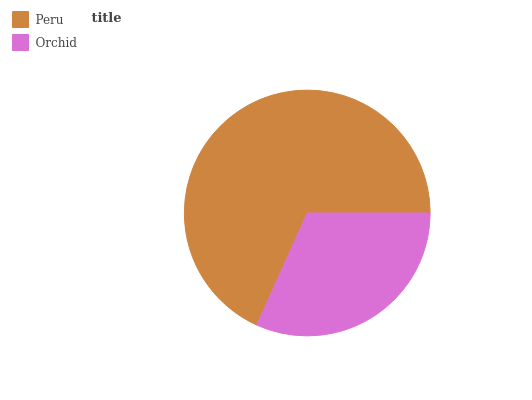Is Orchid the minimum?
Answer yes or no. Yes. Is Peru the maximum?
Answer yes or no. Yes. Is Orchid the maximum?
Answer yes or no. No. Is Peru greater than Orchid?
Answer yes or no. Yes. Is Orchid less than Peru?
Answer yes or no. Yes. Is Orchid greater than Peru?
Answer yes or no. No. Is Peru less than Orchid?
Answer yes or no. No. Is Peru the high median?
Answer yes or no. Yes. Is Orchid the low median?
Answer yes or no. Yes. Is Orchid the high median?
Answer yes or no. No. Is Peru the low median?
Answer yes or no. No. 